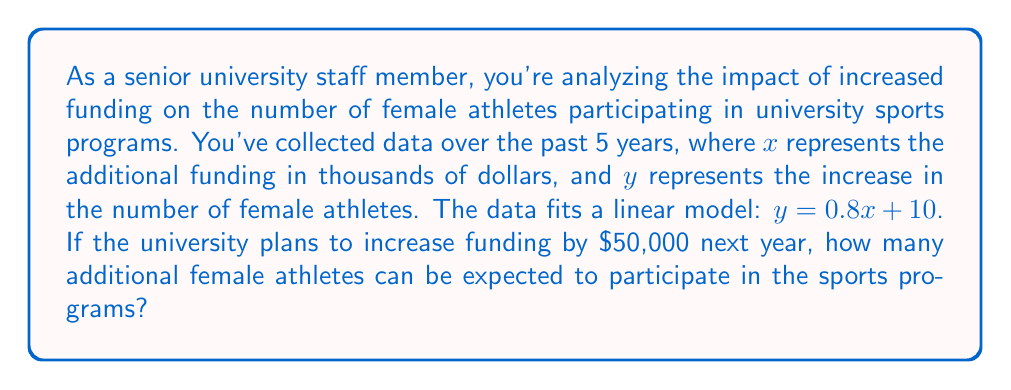Help me with this question. To solve this problem, we'll use the given linear equation and substitute the planned funding increase:

1. The linear model is given as: $y = 0.8x + 10$
   Where:
   $y$ = increase in the number of female athletes
   $x$ = additional funding in thousands of dollars

2. The university plans to increase funding by $50,000, which is 50 in terms of thousands of dollars.

3. Substitute $x = 50$ into the equation:
   $y = 0.8(50) + 10$

4. Solve the equation:
   $y = 40 + 10$
   $y = 50$

5. Interpret the result:
   The model predicts an increase of 50 female athletes with the additional $50,000 in funding.

This linear model demonstrates how increased funding can directly impact gender equality in sports by providing more opportunities for female athletes to participate in university sports programs.
Answer: 50 additional female athletes 